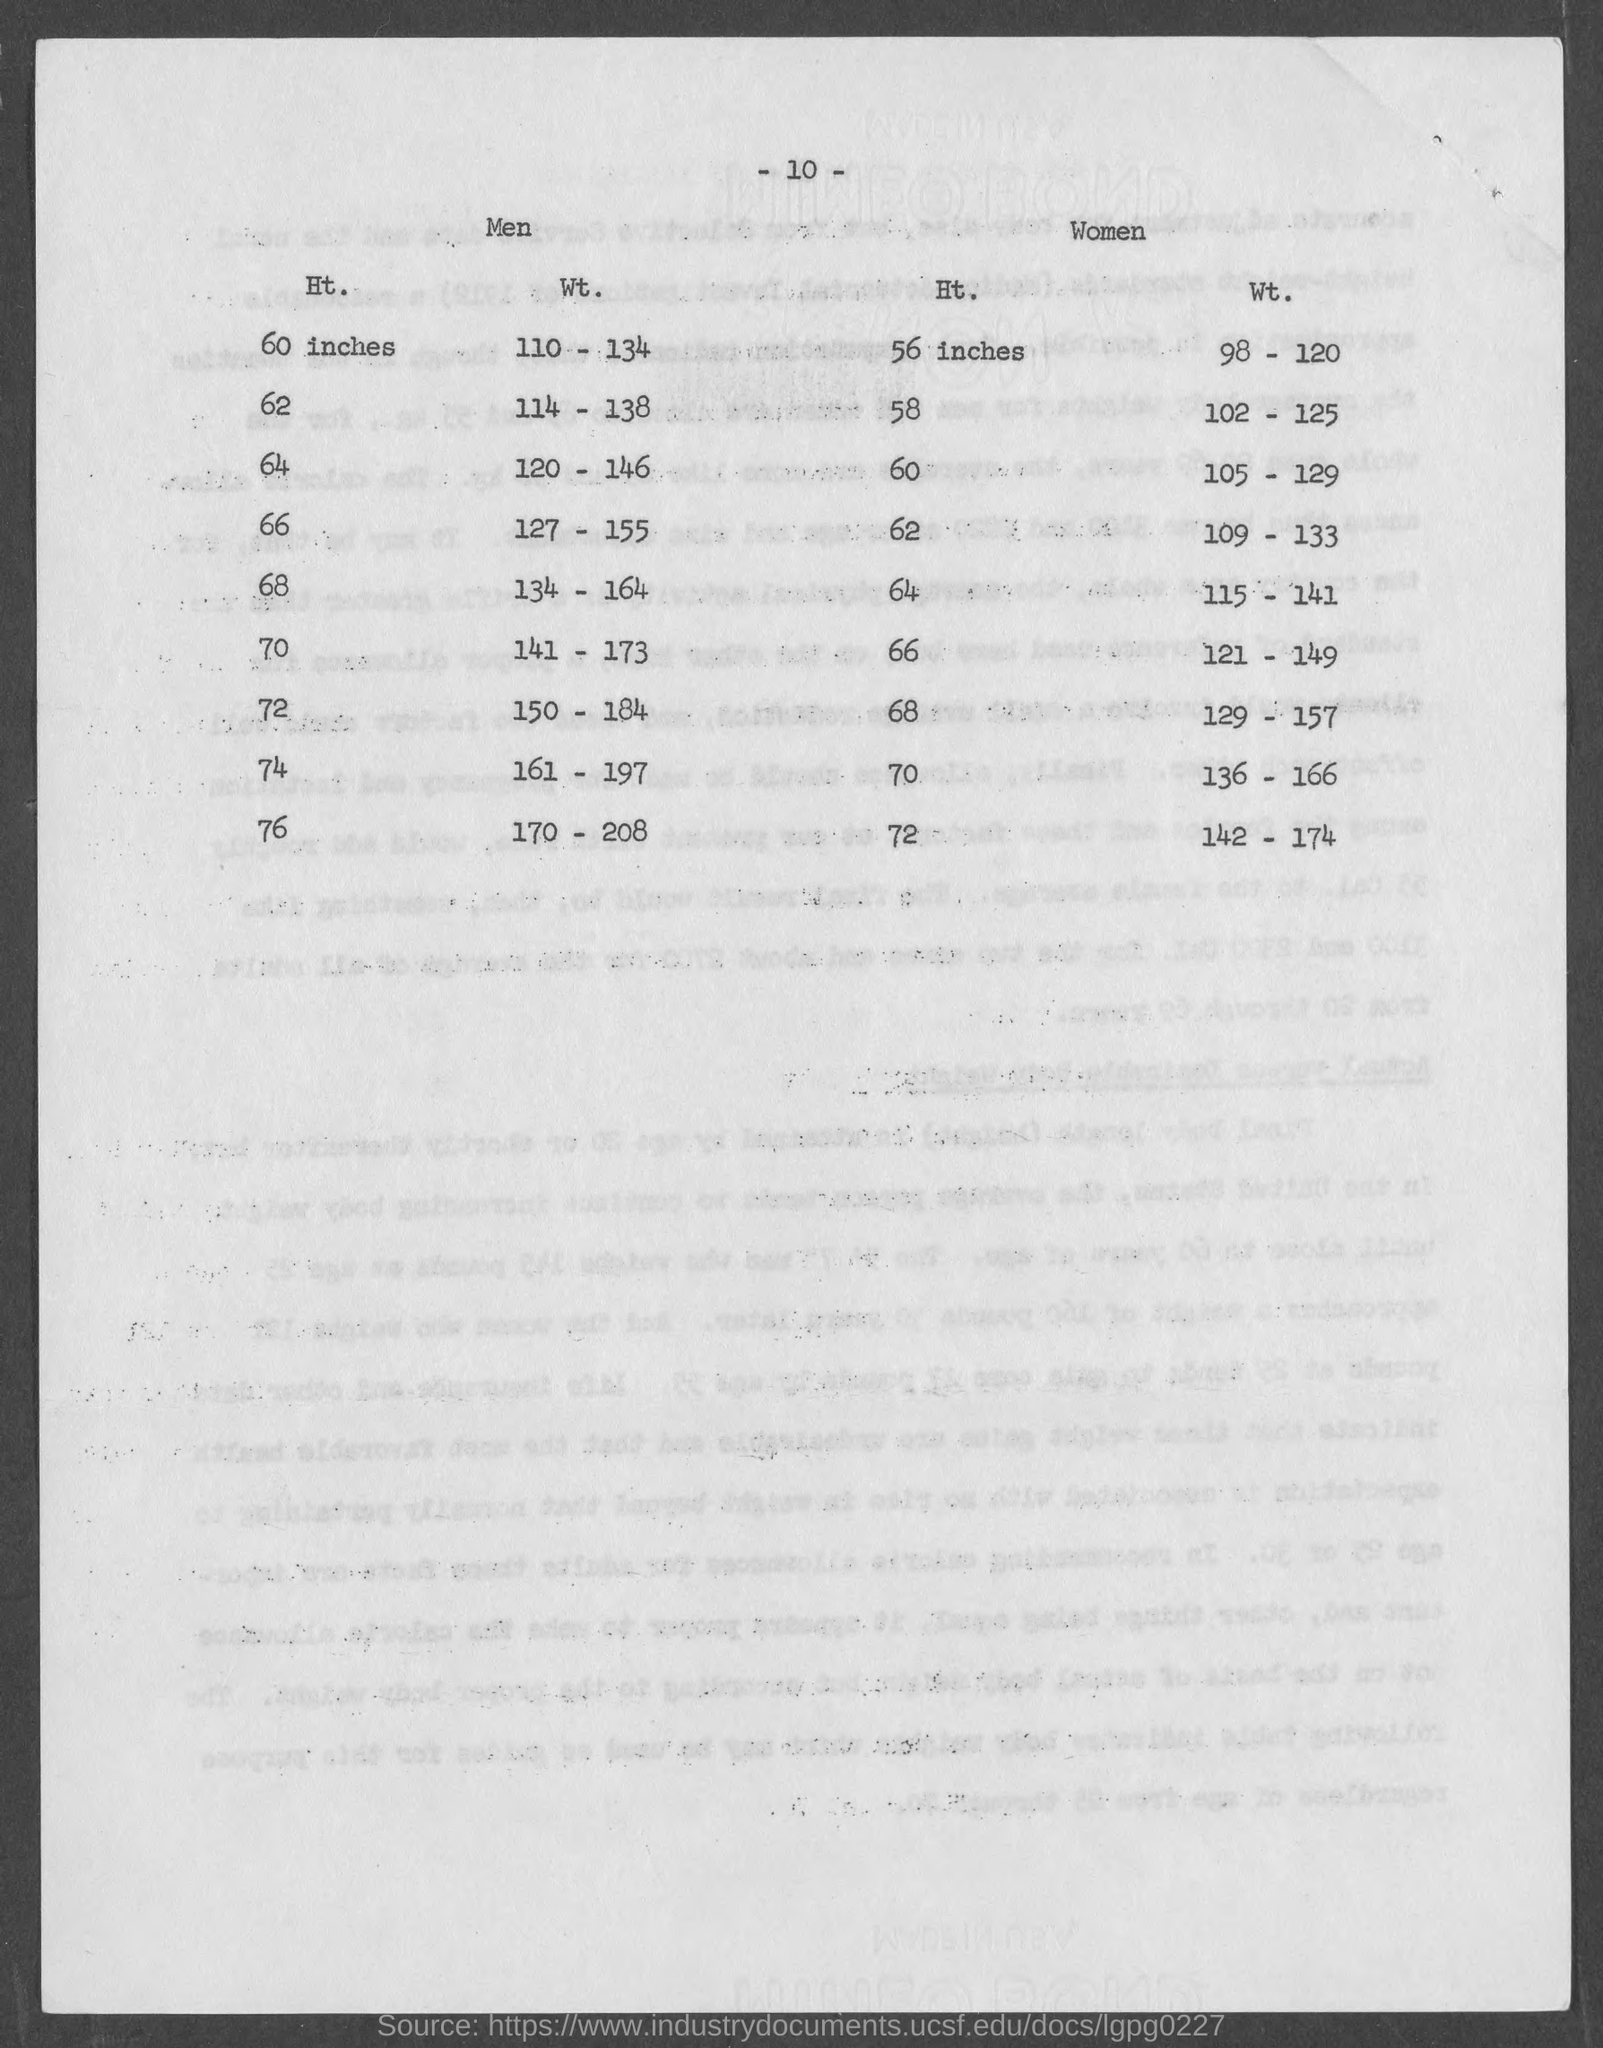Give some essential details in this illustration. For a height of 76 inches in men, the weight must be at least 170 pounds minus 208 pounds. A weight of 134 pounds is required for a height of 68 inches in men, after subtracting 164 pounds. For a height of 70 inches in men, the weight should be around 141 pounds minus 173 pounds. The page number at the top of the page is 10. For a height of 74 inches in men, the weight must be at least 161 pounds less 197 pounds. 